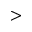<formula> <loc_0><loc_0><loc_500><loc_500>></formula> 